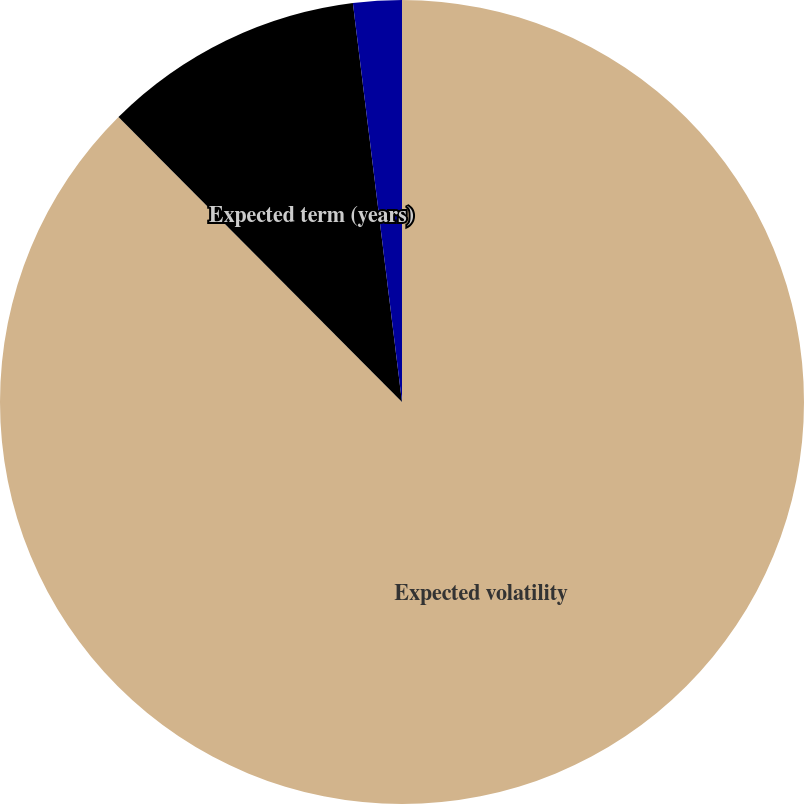<chart> <loc_0><loc_0><loc_500><loc_500><pie_chart><fcel>Expected volatility<fcel>Expected term (years)<fcel>Risk-free interest rate<nl><fcel>87.55%<fcel>10.51%<fcel>1.95%<nl></chart> 